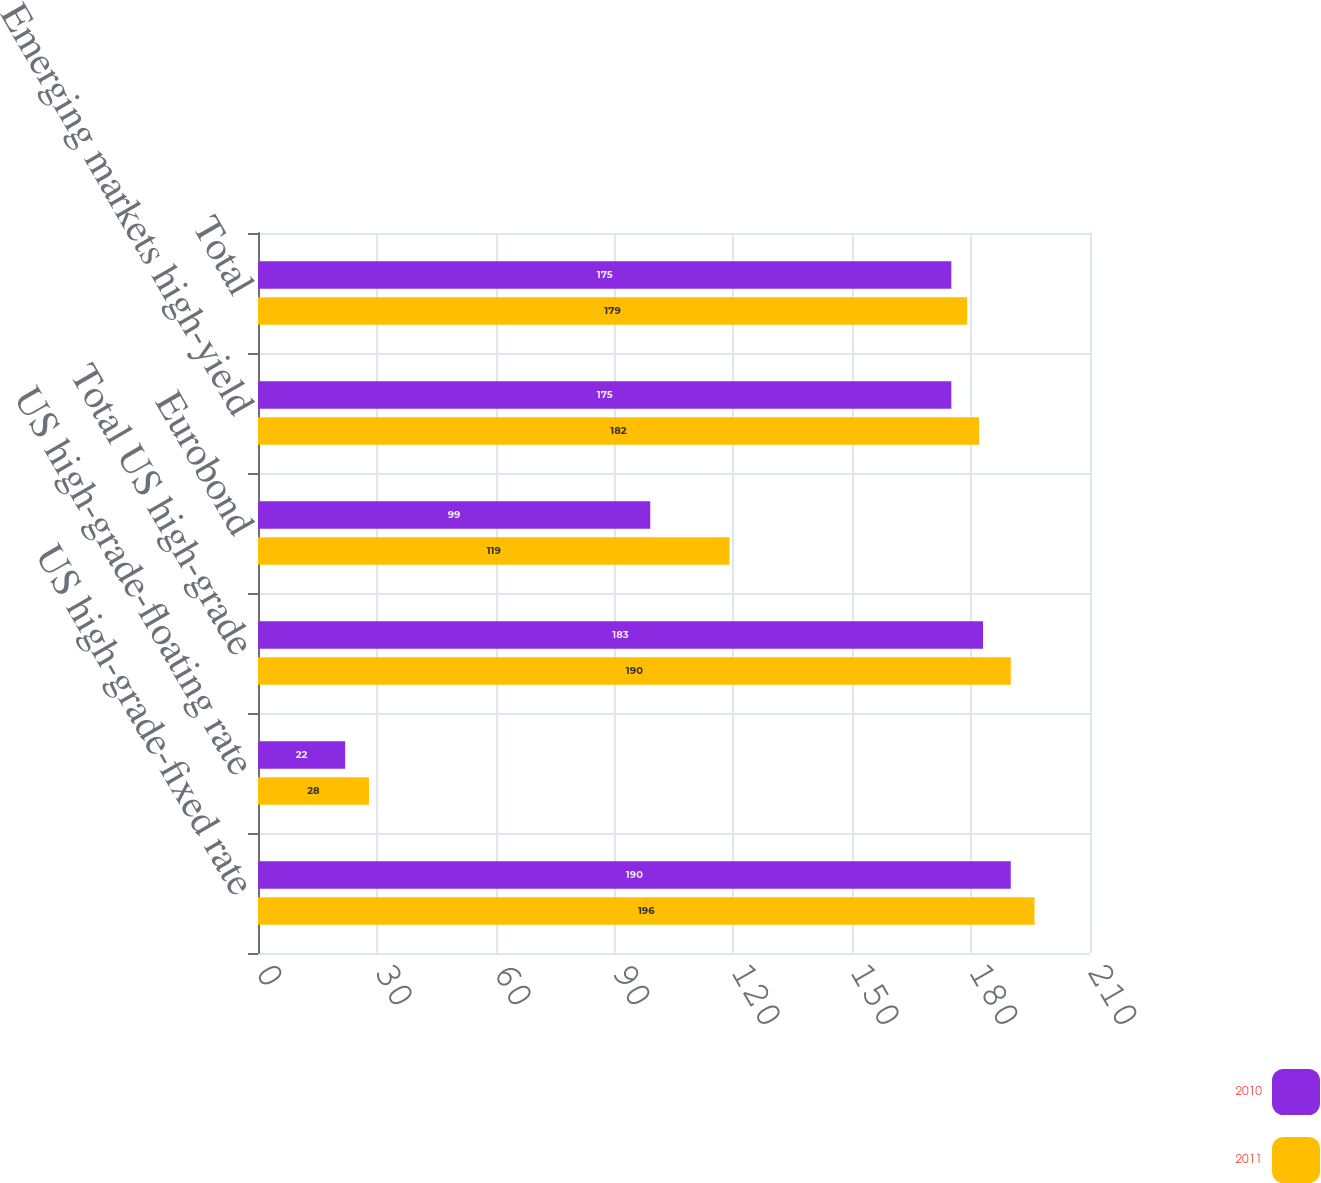Convert chart. <chart><loc_0><loc_0><loc_500><loc_500><stacked_bar_chart><ecel><fcel>US high-grade-fixed rate<fcel>US high-grade-floating rate<fcel>Total US high-grade<fcel>Eurobond<fcel>Emerging markets high-yield<fcel>Total<nl><fcel>2010<fcel>190<fcel>22<fcel>183<fcel>99<fcel>175<fcel>175<nl><fcel>2011<fcel>196<fcel>28<fcel>190<fcel>119<fcel>182<fcel>179<nl></chart> 